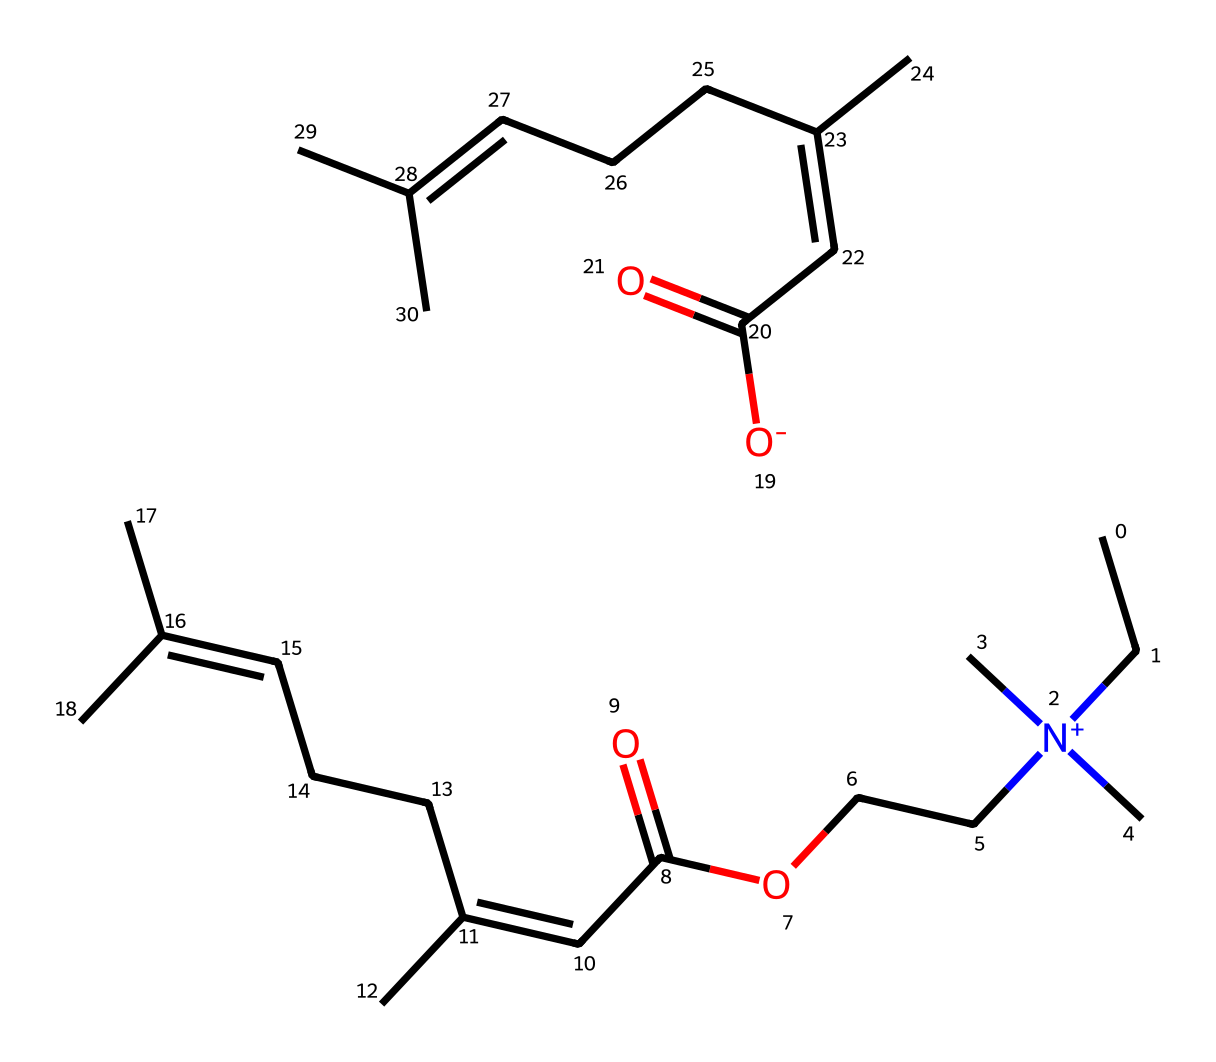What is the total number of carbon atoms in this ionic liquid? By examining the provided SMILES representation, each "C" indicates the presence of a carbon atom. Counting the carbon atoms, there are 20 carbon atoms present in the structure.
Answer: 20 How many functional groups are present in this ionic liquid? Analyzing the chemical structure, we see the presence of an ester group (C(=O)O), as well as multiple double bonds (C=C). Specifically, there are two ester functional groups and numerous double bonds evident in the structure.
Answer: 2 What type of ions are present in this ionic liquid? The presence of the quaternary ammonium group indicated by "N+" denotes a cation while "O-" denotes an anion. Hence, the ionic liquid consists of cations and anions derived from the nitrogen and oxygen atoms, respectively.
Answer: cation and anion Does this ionic liquid contain any aromatic rings? The SMILES representation does not include "c" (indicating aromatic carbon) or any cyclic structures indicative of aromaticity. Thus, this ionic liquid lacks aromatic rings in its structure.
Answer: no What is the expected solubility behavior of this ionic liquid in water? Ionic liquids typically are soluble in polar solvents due to their ionic nature; however, several factors determine this, like hydrophilicity of the cations and anions. Given the structure here with large hydrophobic groups, it may have limited solubility in water.
Answer: limited solubility 